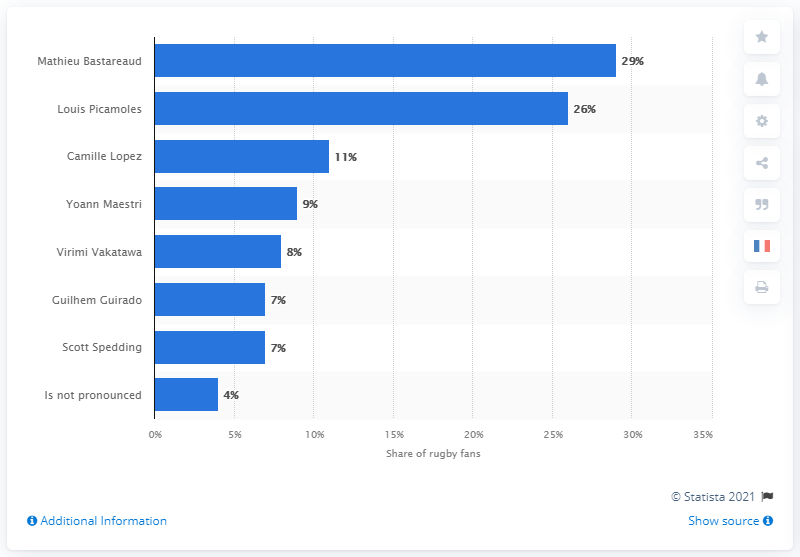Draw attention to some important aspects in this diagram. In 2017, Mathieu Bastareaud was the most popular player on the XV of France. Louis Picamoles has the second highest number of fans among all players. The mode is 7. 